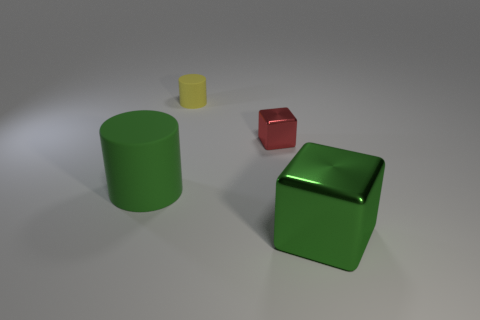There is a metal object that is the same color as the large matte cylinder; what size is it?
Make the answer very short. Large. There is a large rubber object; is it the same color as the large thing to the right of the yellow cylinder?
Your answer should be very brief. Yes. What is the material of the large green thing that is right of the large object on the left side of the cube behind the large green rubber cylinder?
Provide a succinct answer. Metal. Is the shape of the big rubber object the same as the tiny metal thing?
Your response must be concise. No. What material is the tiny red object that is the same shape as the large metallic thing?
Your answer should be very brief. Metal. What number of big cylinders are the same color as the big metallic thing?
Keep it short and to the point. 1. The red object that is the same material as the big green block is what size?
Offer a terse response. Small. What number of red things are either big spheres or small things?
Offer a very short reply. 1. There is a large green thing left of the yellow matte object; how many big green objects are to the left of it?
Ensure brevity in your answer.  0. Are there more blocks to the right of the big shiny object than small yellow objects that are behind the yellow cylinder?
Keep it short and to the point. No. 